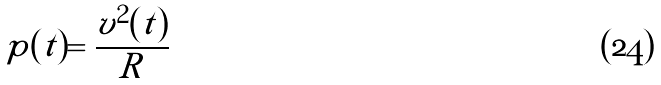Convert formula to latex. <formula><loc_0><loc_0><loc_500><loc_500>p ( t ) = \frac { v ^ { 2 } ( t ) } { R }</formula> 